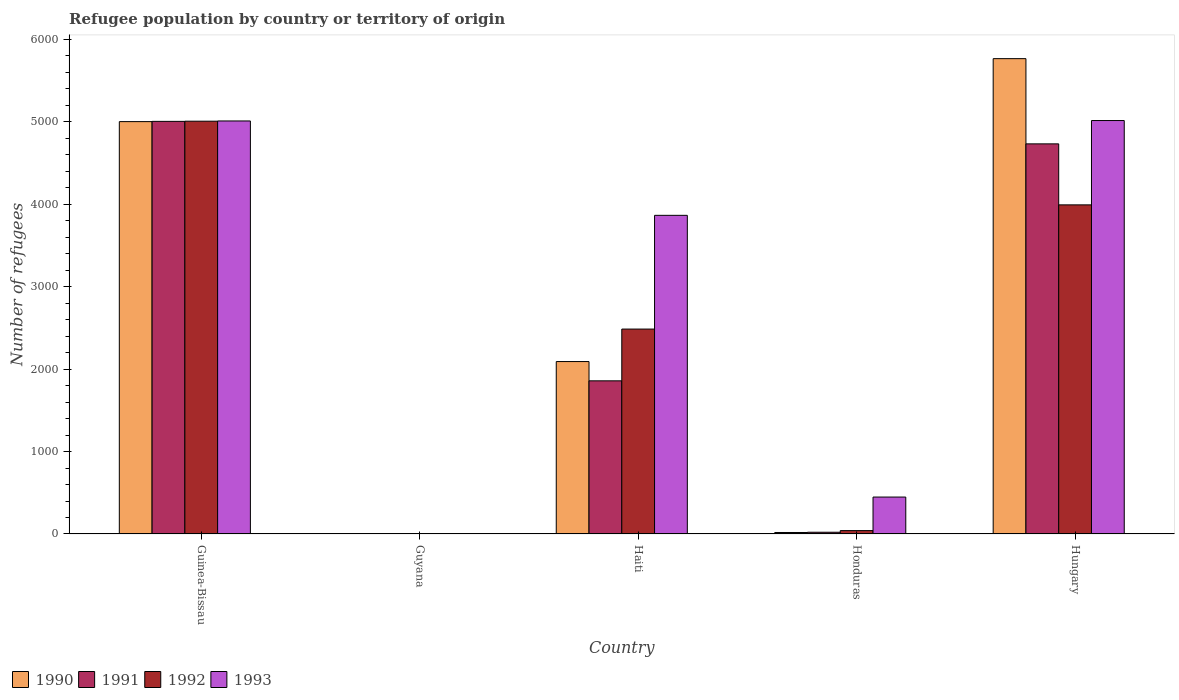Are the number of bars per tick equal to the number of legend labels?
Ensure brevity in your answer.  Yes. Are the number of bars on each tick of the X-axis equal?
Provide a short and direct response. Yes. What is the label of the 2nd group of bars from the left?
Ensure brevity in your answer.  Guyana. Across all countries, what is the maximum number of refugees in 1991?
Your response must be concise. 5006. Across all countries, what is the minimum number of refugees in 1993?
Ensure brevity in your answer.  4. In which country was the number of refugees in 1992 maximum?
Make the answer very short. Guinea-Bissau. In which country was the number of refugees in 1991 minimum?
Keep it short and to the point. Guyana. What is the total number of refugees in 1990 in the graph?
Keep it short and to the point. 1.29e+04. What is the difference between the number of refugees in 1992 in Guinea-Bissau and that in Guyana?
Your answer should be very brief. 5006. What is the difference between the number of refugees in 1992 in Hungary and the number of refugees in 1990 in Haiti?
Offer a very short reply. 1901. What is the average number of refugees in 1992 per country?
Keep it short and to the point. 2306. What is the difference between the number of refugees of/in 1993 and number of refugees of/in 1990 in Hungary?
Offer a terse response. -751. In how many countries, is the number of refugees in 1991 greater than 4200?
Keep it short and to the point. 2. What is the ratio of the number of refugees in 1992 in Guinea-Bissau to that in Haiti?
Make the answer very short. 2.01. Is the number of refugees in 1990 in Haiti less than that in Hungary?
Offer a very short reply. Yes. What is the difference between the highest and the second highest number of refugees in 1993?
Offer a terse response. 1150. What is the difference between the highest and the lowest number of refugees in 1993?
Your response must be concise. 5012. Is the sum of the number of refugees in 1991 in Guinea-Bissau and Haiti greater than the maximum number of refugees in 1992 across all countries?
Offer a terse response. Yes. Is it the case that in every country, the sum of the number of refugees in 1993 and number of refugees in 1991 is greater than the sum of number of refugees in 1990 and number of refugees in 1992?
Your answer should be very brief. No. What does the 4th bar from the right in Haiti represents?
Your response must be concise. 1990. How many bars are there?
Provide a short and direct response. 20. Are all the bars in the graph horizontal?
Give a very brief answer. No. How many countries are there in the graph?
Provide a short and direct response. 5. What is the difference between two consecutive major ticks on the Y-axis?
Keep it short and to the point. 1000. Are the values on the major ticks of Y-axis written in scientific E-notation?
Your answer should be very brief. No. Does the graph contain any zero values?
Your response must be concise. No. Where does the legend appear in the graph?
Give a very brief answer. Bottom left. How are the legend labels stacked?
Your answer should be compact. Horizontal. What is the title of the graph?
Make the answer very short. Refugee population by country or territory of origin. What is the label or title of the Y-axis?
Make the answer very short. Number of refugees. What is the Number of refugees of 1990 in Guinea-Bissau?
Your response must be concise. 5003. What is the Number of refugees in 1991 in Guinea-Bissau?
Provide a succinct answer. 5006. What is the Number of refugees in 1992 in Guinea-Bissau?
Your answer should be compact. 5008. What is the Number of refugees in 1993 in Guinea-Bissau?
Your answer should be very brief. 5011. What is the Number of refugees in 1990 in Guyana?
Your answer should be compact. 2. What is the Number of refugees of 1991 in Guyana?
Your answer should be compact. 1. What is the Number of refugees of 1990 in Haiti?
Offer a terse response. 2092. What is the Number of refugees of 1991 in Haiti?
Make the answer very short. 1858. What is the Number of refugees in 1992 in Haiti?
Make the answer very short. 2486. What is the Number of refugees of 1993 in Haiti?
Provide a succinct answer. 3866. What is the Number of refugees in 1992 in Honduras?
Provide a short and direct response. 41. What is the Number of refugees of 1993 in Honduras?
Offer a very short reply. 448. What is the Number of refugees in 1990 in Hungary?
Offer a very short reply. 5767. What is the Number of refugees of 1991 in Hungary?
Keep it short and to the point. 4733. What is the Number of refugees of 1992 in Hungary?
Keep it short and to the point. 3993. What is the Number of refugees of 1993 in Hungary?
Your answer should be very brief. 5016. Across all countries, what is the maximum Number of refugees of 1990?
Keep it short and to the point. 5767. Across all countries, what is the maximum Number of refugees of 1991?
Offer a terse response. 5006. Across all countries, what is the maximum Number of refugees in 1992?
Ensure brevity in your answer.  5008. Across all countries, what is the maximum Number of refugees of 1993?
Offer a terse response. 5016. Across all countries, what is the minimum Number of refugees of 1992?
Your response must be concise. 2. Across all countries, what is the minimum Number of refugees in 1993?
Your answer should be very brief. 4. What is the total Number of refugees of 1990 in the graph?
Your answer should be very brief. 1.29e+04. What is the total Number of refugees of 1991 in the graph?
Your answer should be compact. 1.16e+04. What is the total Number of refugees in 1992 in the graph?
Keep it short and to the point. 1.15e+04. What is the total Number of refugees in 1993 in the graph?
Keep it short and to the point. 1.43e+04. What is the difference between the Number of refugees of 1990 in Guinea-Bissau and that in Guyana?
Offer a very short reply. 5001. What is the difference between the Number of refugees of 1991 in Guinea-Bissau and that in Guyana?
Offer a terse response. 5005. What is the difference between the Number of refugees in 1992 in Guinea-Bissau and that in Guyana?
Your answer should be compact. 5006. What is the difference between the Number of refugees of 1993 in Guinea-Bissau and that in Guyana?
Provide a succinct answer. 5007. What is the difference between the Number of refugees of 1990 in Guinea-Bissau and that in Haiti?
Offer a very short reply. 2911. What is the difference between the Number of refugees in 1991 in Guinea-Bissau and that in Haiti?
Give a very brief answer. 3148. What is the difference between the Number of refugees of 1992 in Guinea-Bissau and that in Haiti?
Provide a succinct answer. 2522. What is the difference between the Number of refugees of 1993 in Guinea-Bissau and that in Haiti?
Give a very brief answer. 1145. What is the difference between the Number of refugees of 1990 in Guinea-Bissau and that in Honduras?
Keep it short and to the point. 4985. What is the difference between the Number of refugees in 1991 in Guinea-Bissau and that in Honduras?
Provide a short and direct response. 4985. What is the difference between the Number of refugees in 1992 in Guinea-Bissau and that in Honduras?
Make the answer very short. 4967. What is the difference between the Number of refugees of 1993 in Guinea-Bissau and that in Honduras?
Offer a very short reply. 4563. What is the difference between the Number of refugees of 1990 in Guinea-Bissau and that in Hungary?
Provide a short and direct response. -764. What is the difference between the Number of refugees in 1991 in Guinea-Bissau and that in Hungary?
Provide a succinct answer. 273. What is the difference between the Number of refugees in 1992 in Guinea-Bissau and that in Hungary?
Ensure brevity in your answer.  1015. What is the difference between the Number of refugees of 1990 in Guyana and that in Haiti?
Offer a very short reply. -2090. What is the difference between the Number of refugees in 1991 in Guyana and that in Haiti?
Your answer should be very brief. -1857. What is the difference between the Number of refugees in 1992 in Guyana and that in Haiti?
Give a very brief answer. -2484. What is the difference between the Number of refugees of 1993 in Guyana and that in Haiti?
Make the answer very short. -3862. What is the difference between the Number of refugees of 1992 in Guyana and that in Honduras?
Your response must be concise. -39. What is the difference between the Number of refugees of 1993 in Guyana and that in Honduras?
Your answer should be very brief. -444. What is the difference between the Number of refugees in 1990 in Guyana and that in Hungary?
Provide a succinct answer. -5765. What is the difference between the Number of refugees of 1991 in Guyana and that in Hungary?
Provide a short and direct response. -4732. What is the difference between the Number of refugees of 1992 in Guyana and that in Hungary?
Provide a short and direct response. -3991. What is the difference between the Number of refugees in 1993 in Guyana and that in Hungary?
Give a very brief answer. -5012. What is the difference between the Number of refugees of 1990 in Haiti and that in Honduras?
Provide a short and direct response. 2074. What is the difference between the Number of refugees of 1991 in Haiti and that in Honduras?
Make the answer very short. 1837. What is the difference between the Number of refugees of 1992 in Haiti and that in Honduras?
Provide a short and direct response. 2445. What is the difference between the Number of refugees of 1993 in Haiti and that in Honduras?
Provide a succinct answer. 3418. What is the difference between the Number of refugees in 1990 in Haiti and that in Hungary?
Provide a succinct answer. -3675. What is the difference between the Number of refugees in 1991 in Haiti and that in Hungary?
Keep it short and to the point. -2875. What is the difference between the Number of refugees of 1992 in Haiti and that in Hungary?
Your answer should be very brief. -1507. What is the difference between the Number of refugees in 1993 in Haiti and that in Hungary?
Make the answer very short. -1150. What is the difference between the Number of refugees in 1990 in Honduras and that in Hungary?
Provide a succinct answer. -5749. What is the difference between the Number of refugees of 1991 in Honduras and that in Hungary?
Ensure brevity in your answer.  -4712. What is the difference between the Number of refugees of 1992 in Honduras and that in Hungary?
Your response must be concise. -3952. What is the difference between the Number of refugees in 1993 in Honduras and that in Hungary?
Offer a very short reply. -4568. What is the difference between the Number of refugees of 1990 in Guinea-Bissau and the Number of refugees of 1991 in Guyana?
Give a very brief answer. 5002. What is the difference between the Number of refugees of 1990 in Guinea-Bissau and the Number of refugees of 1992 in Guyana?
Make the answer very short. 5001. What is the difference between the Number of refugees of 1990 in Guinea-Bissau and the Number of refugees of 1993 in Guyana?
Your answer should be compact. 4999. What is the difference between the Number of refugees of 1991 in Guinea-Bissau and the Number of refugees of 1992 in Guyana?
Ensure brevity in your answer.  5004. What is the difference between the Number of refugees in 1991 in Guinea-Bissau and the Number of refugees in 1993 in Guyana?
Give a very brief answer. 5002. What is the difference between the Number of refugees of 1992 in Guinea-Bissau and the Number of refugees of 1993 in Guyana?
Make the answer very short. 5004. What is the difference between the Number of refugees in 1990 in Guinea-Bissau and the Number of refugees in 1991 in Haiti?
Your answer should be very brief. 3145. What is the difference between the Number of refugees in 1990 in Guinea-Bissau and the Number of refugees in 1992 in Haiti?
Make the answer very short. 2517. What is the difference between the Number of refugees in 1990 in Guinea-Bissau and the Number of refugees in 1993 in Haiti?
Your answer should be compact. 1137. What is the difference between the Number of refugees of 1991 in Guinea-Bissau and the Number of refugees of 1992 in Haiti?
Offer a terse response. 2520. What is the difference between the Number of refugees in 1991 in Guinea-Bissau and the Number of refugees in 1993 in Haiti?
Keep it short and to the point. 1140. What is the difference between the Number of refugees in 1992 in Guinea-Bissau and the Number of refugees in 1993 in Haiti?
Ensure brevity in your answer.  1142. What is the difference between the Number of refugees of 1990 in Guinea-Bissau and the Number of refugees of 1991 in Honduras?
Your answer should be very brief. 4982. What is the difference between the Number of refugees of 1990 in Guinea-Bissau and the Number of refugees of 1992 in Honduras?
Your answer should be very brief. 4962. What is the difference between the Number of refugees of 1990 in Guinea-Bissau and the Number of refugees of 1993 in Honduras?
Provide a short and direct response. 4555. What is the difference between the Number of refugees of 1991 in Guinea-Bissau and the Number of refugees of 1992 in Honduras?
Provide a succinct answer. 4965. What is the difference between the Number of refugees of 1991 in Guinea-Bissau and the Number of refugees of 1993 in Honduras?
Provide a short and direct response. 4558. What is the difference between the Number of refugees in 1992 in Guinea-Bissau and the Number of refugees in 1993 in Honduras?
Your response must be concise. 4560. What is the difference between the Number of refugees of 1990 in Guinea-Bissau and the Number of refugees of 1991 in Hungary?
Your answer should be compact. 270. What is the difference between the Number of refugees in 1990 in Guinea-Bissau and the Number of refugees in 1992 in Hungary?
Offer a very short reply. 1010. What is the difference between the Number of refugees in 1990 in Guinea-Bissau and the Number of refugees in 1993 in Hungary?
Provide a short and direct response. -13. What is the difference between the Number of refugees in 1991 in Guinea-Bissau and the Number of refugees in 1992 in Hungary?
Keep it short and to the point. 1013. What is the difference between the Number of refugees in 1991 in Guinea-Bissau and the Number of refugees in 1993 in Hungary?
Ensure brevity in your answer.  -10. What is the difference between the Number of refugees of 1992 in Guinea-Bissau and the Number of refugees of 1993 in Hungary?
Your answer should be compact. -8. What is the difference between the Number of refugees of 1990 in Guyana and the Number of refugees of 1991 in Haiti?
Provide a succinct answer. -1856. What is the difference between the Number of refugees of 1990 in Guyana and the Number of refugees of 1992 in Haiti?
Your response must be concise. -2484. What is the difference between the Number of refugees in 1990 in Guyana and the Number of refugees in 1993 in Haiti?
Give a very brief answer. -3864. What is the difference between the Number of refugees in 1991 in Guyana and the Number of refugees in 1992 in Haiti?
Your response must be concise. -2485. What is the difference between the Number of refugees in 1991 in Guyana and the Number of refugees in 1993 in Haiti?
Provide a short and direct response. -3865. What is the difference between the Number of refugees in 1992 in Guyana and the Number of refugees in 1993 in Haiti?
Offer a very short reply. -3864. What is the difference between the Number of refugees of 1990 in Guyana and the Number of refugees of 1991 in Honduras?
Offer a terse response. -19. What is the difference between the Number of refugees in 1990 in Guyana and the Number of refugees in 1992 in Honduras?
Ensure brevity in your answer.  -39. What is the difference between the Number of refugees of 1990 in Guyana and the Number of refugees of 1993 in Honduras?
Ensure brevity in your answer.  -446. What is the difference between the Number of refugees of 1991 in Guyana and the Number of refugees of 1992 in Honduras?
Your response must be concise. -40. What is the difference between the Number of refugees of 1991 in Guyana and the Number of refugees of 1993 in Honduras?
Offer a very short reply. -447. What is the difference between the Number of refugees of 1992 in Guyana and the Number of refugees of 1993 in Honduras?
Your answer should be compact. -446. What is the difference between the Number of refugees in 1990 in Guyana and the Number of refugees in 1991 in Hungary?
Your response must be concise. -4731. What is the difference between the Number of refugees of 1990 in Guyana and the Number of refugees of 1992 in Hungary?
Provide a short and direct response. -3991. What is the difference between the Number of refugees of 1990 in Guyana and the Number of refugees of 1993 in Hungary?
Provide a succinct answer. -5014. What is the difference between the Number of refugees of 1991 in Guyana and the Number of refugees of 1992 in Hungary?
Provide a succinct answer. -3992. What is the difference between the Number of refugees in 1991 in Guyana and the Number of refugees in 1993 in Hungary?
Ensure brevity in your answer.  -5015. What is the difference between the Number of refugees in 1992 in Guyana and the Number of refugees in 1993 in Hungary?
Offer a terse response. -5014. What is the difference between the Number of refugees of 1990 in Haiti and the Number of refugees of 1991 in Honduras?
Offer a very short reply. 2071. What is the difference between the Number of refugees in 1990 in Haiti and the Number of refugees in 1992 in Honduras?
Give a very brief answer. 2051. What is the difference between the Number of refugees of 1990 in Haiti and the Number of refugees of 1993 in Honduras?
Make the answer very short. 1644. What is the difference between the Number of refugees of 1991 in Haiti and the Number of refugees of 1992 in Honduras?
Give a very brief answer. 1817. What is the difference between the Number of refugees of 1991 in Haiti and the Number of refugees of 1993 in Honduras?
Ensure brevity in your answer.  1410. What is the difference between the Number of refugees of 1992 in Haiti and the Number of refugees of 1993 in Honduras?
Offer a terse response. 2038. What is the difference between the Number of refugees in 1990 in Haiti and the Number of refugees in 1991 in Hungary?
Your answer should be very brief. -2641. What is the difference between the Number of refugees in 1990 in Haiti and the Number of refugees in 1992 in Hungary?
Offer a terse response. -1901. What is the difference between the Number of refugees of 1990 in Haiti and the Number of refugees of 1993 in Hungary?
Offer a terse response. -2924. What is the difference between the Number of refugees of 1991 in Haiti and the Number of refugees of 1992 in Hungary?
Keep it short and to the point. -2135. What is the difference between the Number of refugees in 1991 in Haiti and the Number of refugees in 1993 in Hungary?
Give a very brief answer. -3158. What is the difference between the Number of refugees of 1992 in Haiti and the Number of refugees of 1993 in Hungary?
Your answer should be very brief. -2530. What is the difference between the Number of refugees of 1990 in Honduras and the Number of refugees of 1991 in Hungary?
Offer a terse response. -4715. What is the difference between the Number of refugees in 1990 in Honduras and the Number of refugees in 1992 in Hungary?
Give a very brief answer. -3975. What is the difference between the Number of refugees of 1990 in Honduras and the Number of refugees of 1993 in Hungary?
Offer a terse response. -4998. What is the difference between the Number of refugees of 1991 in Honduras and the Number of refugees of 1992 in Hungary?
Provide a succinct answer. -3972. What is the difference between the Number of refugees in 1991 in Honduras and the Number of refugees in 1993 in Hungary?
Offer a very short reply. -4995. What is the difference between the Number of refugees in 1992 in Honduras and the Number of refugees in 1993 in Hungary?
Keep it short and to the point. -4975. What is the average Number of refugees of 1990 per country?
Provide a succinct answer. 2576.4. What is the average Number of refugees in 1991 per country?
Your answer should be very brief. 2323.8. What is the average Number of refugees of 1992 per country?
Provide a short and direct response. 2306. What is the average Number of refugees in 1993 per country?
Provide a succinct answer. 2869. What is the difference between the Number of refugees of 1990 and Number of refugees of 1991 in Guinea-Bissau?
Provide a short and direct response. -3. What is the difference between the Number of refugees in 1990 and Number of refugees in 1992 in Guinea-Bissau?
Your response must be concise. -5. What is the difference between the Number of refugees of 1990 and Number of refugees of 1993 in Guinea-Bissau?
Provide a succinct answer. -8. What is the difference between the Number of refugees in 1991 and Number of refugees in 1993 in Guinea-Bissau?
Make the answer very short. -5. What is the difference between the Number of refugees of 1992 and Number of refugees of 1993 in Guinea-Bissau?
Ensure brevity in your answer.  -3. What is the difference between the Number of refugees of 1990 and Number of refugees of 1991 in Guyana?
Provide a succinct answer. 1. What is the difference between the Number of refugees in 1990 and Number of refugees in 1992 in Guyana?
Ensure brevity in your answer.  0. What is the difference between the Number of refugees of 1990 and Number of refugees of 1993 in Guyana?
Ensure brevity in your answer.  -2. What is the difference between the Number of refugees in 1991 and Number of refugees in 1993 in Guyana?
Provide a short and direct response. -3. What is the difference between the Number of refugees in 1990 and Number of refugees in 1991 in Haiti?
Your response must be concise. 234. What is the difference between the Number of refugees of 1990 and Number of refugees of 1992 in Haiti?
Your response must be concise. -394. What is the difference between the Number of refugees of 1990 and Number of refugees of 1993 in Haiti?
Provide a succinct answer. -1774. What is the difference between the Number of refugees of 1991 and Number of refugees of 1992 in Haiti?
Your response must be concise. -628. What is the difference between the Number of refugees in 1991 and Number of refugees in 1993 in Haiti?
Offer a terse response. -2008. What is the difference between the Number of refugees in 1992 and Number of refugees in 1993 in Haiti?
Your response must be concise. -1380. What is the difference between the Number of refugees in 1990 and Number of refugees in 1991 in Honduras?
Keep it short and to the point. -3. What is the difference between the Number of refugees of 1990 and Number of refugees of 1993 in Honduras?
Ensure brevity in your answer.  -430. What is the difference between the Number of refugees of 1991 and Number of refugees of 1993 in Honduras?
Your response must be concise. -427. What is the difference between the Number of refugees of 1992 and Number of refugees of 1993 in Honduras?
Provide a succinct answer. -407. What is the difference between the Number of refugees of 1990 and Number of refugees of 1991 in Hungary?
Offer a very short reply. 1034. What is the difference between the Number of refugees in 1990 and Number of refugees in 1992 in Hungary?
Make the answer very short. 1774. What is the difference between the Number of refugees in 1990 and Number of refugees in 1993 in Hungary?
Keep it short and to the point. 751. What is the difference between the Number of refugees of 1991 and Number of refugees of 1992 in Hungary?
Provide a succinct answer. 740. What is the difference between the Number of refugees in 1991 and Number of refugees in 1993 in Hungary?
Offer a very short reply. -283. What is the difference between the Number of refugees of 1992 and Number of refugees of 1993 in Hungary?
Your answer should be very brief. -1023. What is the ratio of the Number of refugees of 1990 in Guinea-Bissau to that in Guyana?
Make the answer very short. 2501.5. What is the ratio of the Number of refugees in 1991 in Guinea-Bissau to that in Guyana?
Your answer should be compact. 5006. What is the ratio of the Number of refugees of 1992 in Guinea-Bissau to that in Guyana?
Make the answer very short. 2504. What is the ratio of the Number of refugees of 1993 in Guinea-Bissau to that in Guyana?
Provide a succinct answer. 1252.75. What is the ratio of the Number of refugees of 1990 in Guinea-Bissau to that in Haiti?
Give a very brief answer. 2.39. What is the ratio of the Number of refugees in 1991 in Guinea-Bissau to that in Haiti?
Keep it short and to the point. 2.69. What is the ratio of the Number of refugees of 1992 in Guinea-Bissau to that in Haiti?
Provide a succinct answer. 2.01. What is the ratio of the Number of refugees of 1993 in Guinea-Bissau to that in Haiti?
Keep it short and to the point. 1.3. What is the ratio of the Number of refugees in 1990 in Guinea-Bissau to that in Honduras?
Provide a succinct answer. 277.94. What is the ratio of the Number of refugees of 1991 in Guinea-Bissau to that in Honduras?
Keep it short and to the point. 238.38. What is the ratio of the Number of refugees in 1992 in Guinea-Bissau to that in Honduras?
Offer a terse response. 122.15. What is the ratio of the Number of refugees of 1993 in Guinea-Bissau to that in Honduras?
Offer a very short reply. 11.19. What is the ratio of the Number of refugees in 1990 in Guinea-Bissau to that in Hungary?
Provide a succinct answer. 0.87. What is the ratio of the Number of refugees of 1991 in Guinea-Bissau to that in Hungary?
Give a very brief answer. 1.06. What is the ratio of the Number of refugees of 1992 in Guinea-Bissau to that in Hungary?
Your answer should be compact. 1.25. What is the ratio of the Number of refugees of 1993 in Guinea-Bissau to that in Hungary?
Provide a succinct answer. 1. What is the ratio of the Number of refugees in 1992 in Guyana to that in Haiti?
Your response must be concise. 0. What is the ratio of the Number of refugees in 1990 in Guyana to that in Honduras?
Make the answer very short. 0.11. What is the ratio of the Number of refugees of 1991 in Guyana to that in Honduras?
Provide a short and direct response. 0.05. What is the ratio of the Number of refugees of 1992 in Guyana to that in Honduras?
Provide a short and direct response. 0.05. What is the ratio of the Number of refugees in 1993 in Guyana to that in Honduras?
Give a very brief answer. 0.01. What is the ratio of the Number of refugees in 1990 in Guyana to that in Hungary?
Give a very brief answer. 0. What is the ratio of the Number of refugees of 1991 in Guyana to that in Hungary?
Provide a succinct answer. 0. What is the ratio of the Number of refugees in 1993 in Guyana to that in Hungary?
Your answer should be compact. 0. What is the ratio of the Number of refugees in 1990 in Haiti to that in Honduras?
Your response must be concise. 116.22. What is the ratio of the Number of refugees of 1991 in Haiti to that in Honduras?
Give a very brief answer. 88.48. What is the ratio of the Number of refugees in 1992 in Haiti to that in Honduras?
Your answer should be very brief. 60.63. What is the ratio of the Number of refugees of 1993 in Haiti to that in Honduras?
Provide a short and direct response. 8.63. What is the ratio of the Number of refugees in 1990 in Haiti to that in Hungary?
Provide a succinct answer. 0.36. What is the ratio of the Number of refugees in 1991 in Haiti to that in Hungary?
Give a very brief answer. 0.39. What is the ratio of the Number of refugees of 1992 in Haiti to that in Hungary?
Offer a terse response. 0.62. What is the ratio of the Number of refugees in 1993 in Haiti to that in Hungary?
Keep it short and to the point. 0.77. What is the ratio of the Number of refugees in 1990 in Honduras to that in Hungary?
Keep it short and to the point. 0. What is the ratio of the Number of refugees of 1991 in Honduras to that in Hungary?
Keep it short and to the point. 0. What is the ratio of the Number of refugees of 1992 in Honduras to that in Hungary?
Give a very brief answer. 0.01. What is the ratio of the Number of refugees in 1993 in Honduras to that in Hungary?
Ensure brevity in your answer.  0.09. What is the difference between the highest and the second highest Number of refugees in 1990?
Your answer should be compact. 764. What is the difference between the highest and the second highest Number of refugees in 1991?
Provide a short and direct response. 273. What is the difference between the highest and the second highest Number of refugees of 1992?
Your response must be concise. 1015. What is the difference between the highest and the lowest Number of refugees in 1990?
Your answer should be very brief. 5765. What is the difference between the highest and the lowest Number of refugees in 1991?
Keep it short and to the point. 5005. What is the difference between the highest and the lowest Number of refugees in 1992?
Offer a very short reply. 5006. What is the difference between the highest and the lowest Number of refugees in 1993?
Your answer should be compact. 5012. 